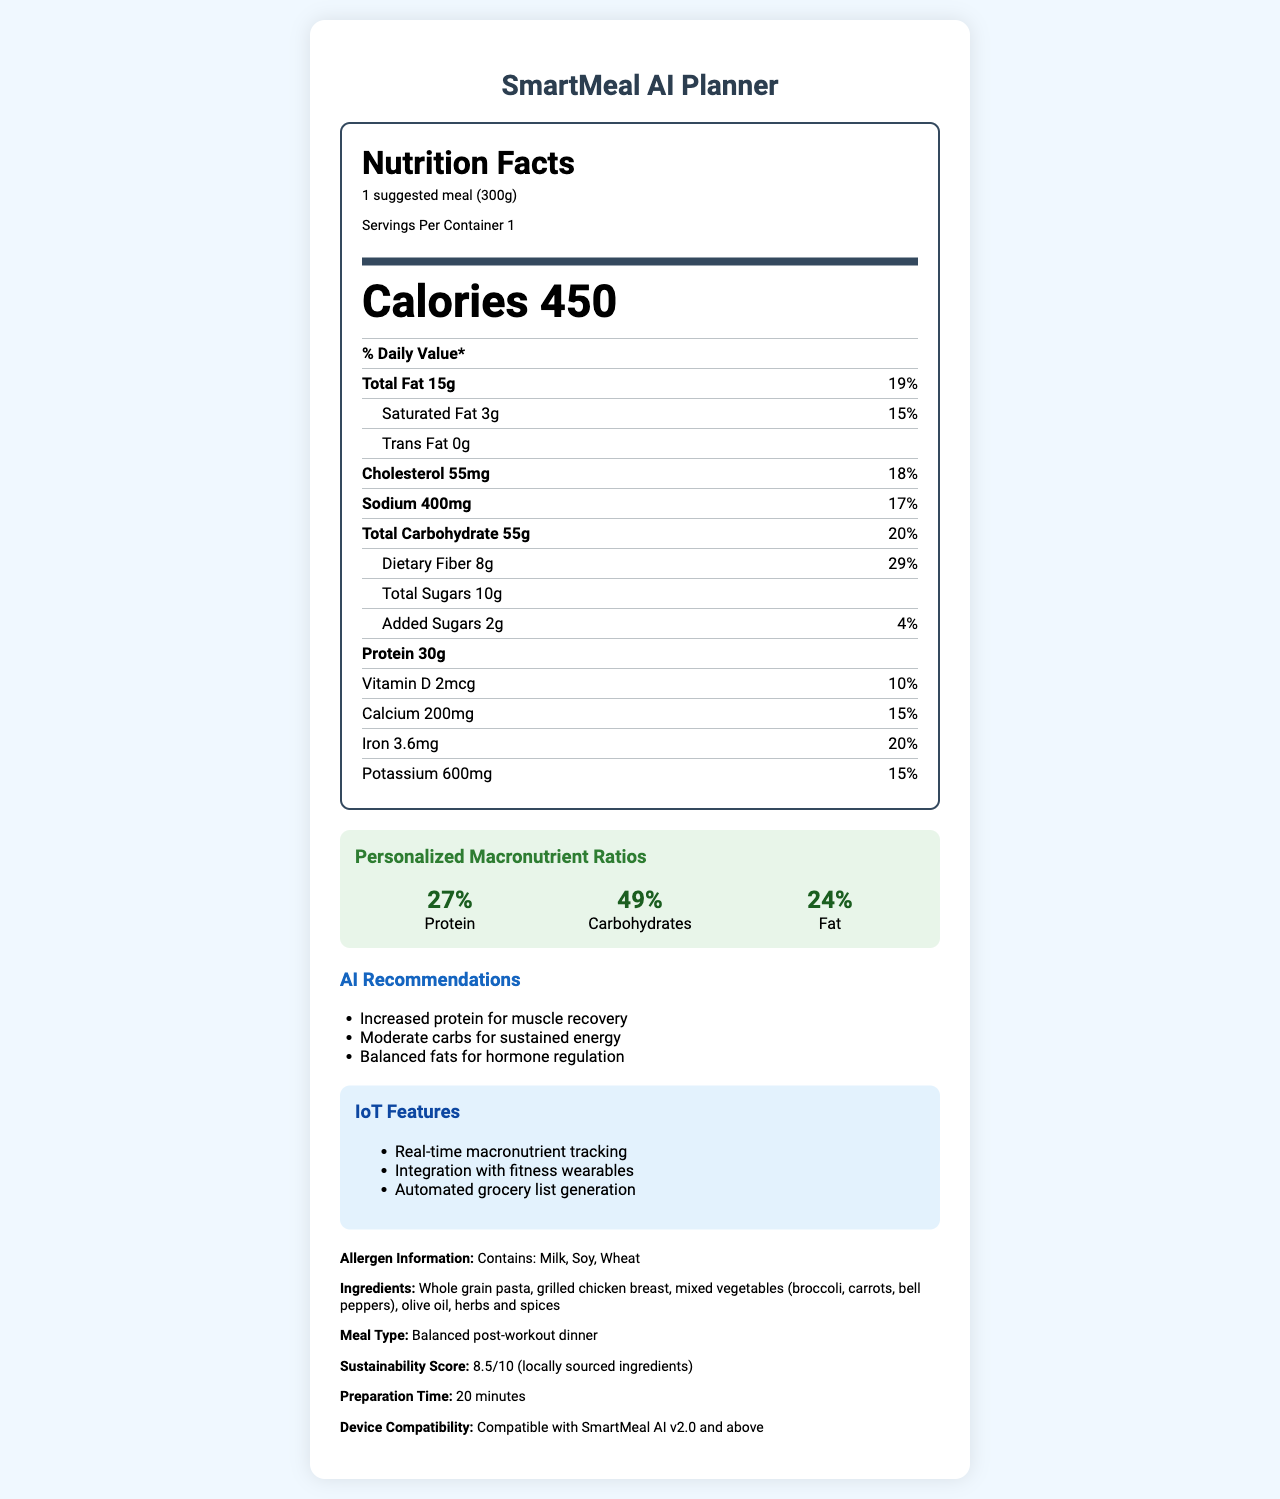what is the serving size? The serving size is explicitly stated at the beginning of the nutrition label.
Answer: 1 suggested meal (300g) how many calories are in one serving? The number of calories per serving is listed prominently in the document.
Answer: 450 how much dietary fiber does this meal contain? The amount of dietary fiber is listed under the total carbohydrate section.
Answer: 8g what are the three AI recommendations provided? The AI recommendations are specifically listed in the "AI Recommendations" section.
Answer: Increased protein for muscle recovery, Moderate carbs for sustained energy, Balanced fats for hormone regulation which allergens are contained in this meal? The allergen information is given at the end of the document, under "Allergen Information."
Answer: Milk, Soy, Wheat what percentage of the daily value of iron does this meal provide? The daily value percentage for iron is listed in the nutrition facts.
Answer: 20% how much added sugar is in this meal? The amount of added sugars is stated in the nutrient list.
Answer: 2g what is the sustainability score for this meal? The sustainability score is explicitly stated in the last section of additional information.
Answer: 8.5/10 which of the following features is NOT an IoT feature listed in the document? A. Real-time macronutrient tracking B. Remote cooking control C. Automated grocery list generation The IoT features listed are real-time macronutrient tracking, integration with fitness wearables, and automated grocery list generation.
Answer: B how much calcium does this meal provide in milligrams? A. 100mg B. 150mg C. 200mg D. 250mg The document states that the calcium amount is 200mg.
Answer: C is this meal compatible with SmartMeal AI v1.0? The document specifies that the meal is compatible with SmartMeal AI v2.0 and above.
Answer: No summarize the main features and nutritional aspects of this document. The summary encapsulates the main points, including nutritional details and special features provided by the document.
Answer: The document is a Nutrition Facts label for the SmartMeal AI Planner. It highlights the nutritional content including calories, macronutrients, and daily values. Additionally, it provides personalized macronutrient ratios, AI recommendations, IoT features, and information about allergens, ingredients, meal type, sustainability score, preparation time, and device compatibility. how many carbohydrates are in one serving of this meal? The document states both the amount (55g) and percentage daily value (20%) of total carbohydrates but doesn't mention through multi-step reasoning.
Answer: Cannot be determined what is the percentage of daily value for sodium? The percentage of daily value for sodium is listed next to its amount.
Answer: 17% what is the preparation time for this meal? The preparation time is listed at the end of the document in the additional info section.
Answer: 20 minutes why is increased protein recommended by the AI? One of the AI recommendations states the reason for increased protein as muscle recovery.
Answer: For muscle recovery how much saturated fat does this meal contain? The amount of saturated fat is listed under the total fat section.
Answer: 3g what vitamins and minerals are included in the nutrition label? These vitamins and minerals are all specifically listed in the nutrition label.
Answer: Vitamin D, Calcium, Iron, Potassium 